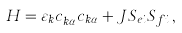<formula> <loc_0><loc_0><loc_500><loc_500>H = \varepsilon _ { k } c ^ { \dag } _ { { k } \alpha } c _ { { k } \alpha } + J { S } _ { e i } { S } _ { f i } \, ,</formula> 